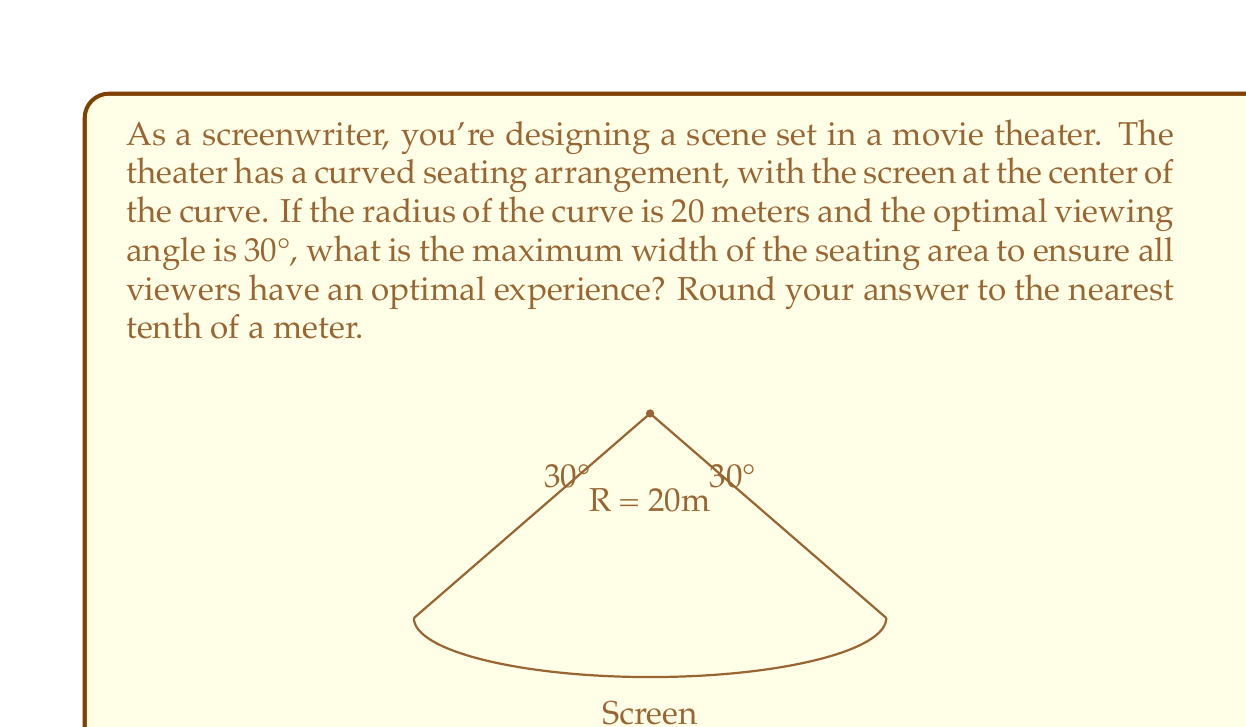Teach me how to tackle this problem. To solve this problem, we'll use trigonometry to find the chord length of the arc that represents the seating area:

1) In a circle, the relationship between the central angle $\theta$ (in radians), the radius $r$, and the chord length $c$ is given by:

   $$c = 2r \sin(\frac{\theta}{2})$$

2) We're given the radius $r = 20$ meters and the angle $\theta = 30° = 30 \times \frac{\pi}{180} = \frac{\pi}{6}$ radians.

3) Substituting these values into the formula:

   $$c = 2 \times 20 \times \sin(\frac{\pi}{12})$$

4) Using a calculator or trigonometric tables:

   $$c = 40 \times \sin(\frac{\pi}{12}) \approx 40 \times 0.2588 \approx 10.3528$$

5) Rounding to the nearest tenth:

   $$c \approx 10.4\text{ meters}$$

This chord length represents the maximum width of the seating area that ensures all viewers are within the optimal 30° viewing angle.
Answer: The maximum width of the seating area is approximately 10.4 meters. 